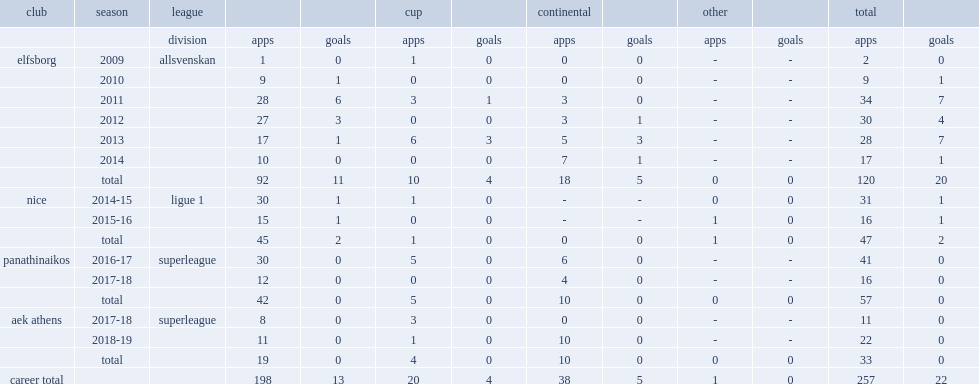Which league did niklas hult appear in club nice for the 2014-15 season? Ligue 1. 